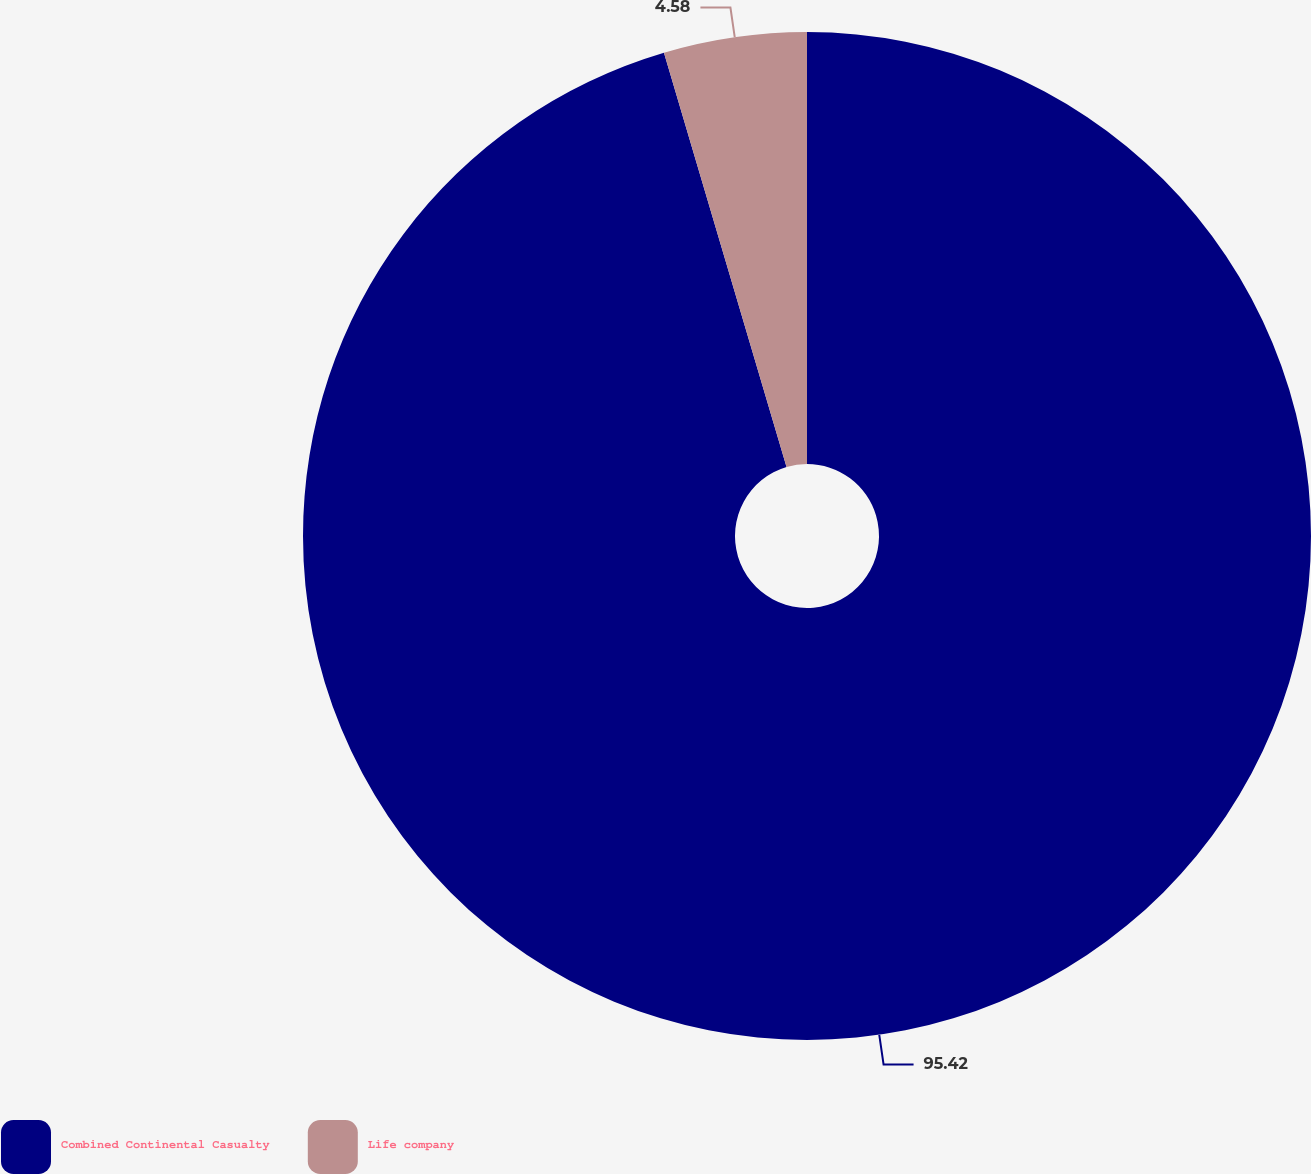Convert chart. <chart><loc_0><loc_0><loc_500><loc_500><pie_chart><fcel>Combined Continental Casualty<fcel>Life company<nl><fcel>95.42%<fcel>4.58%<nl></chart> 